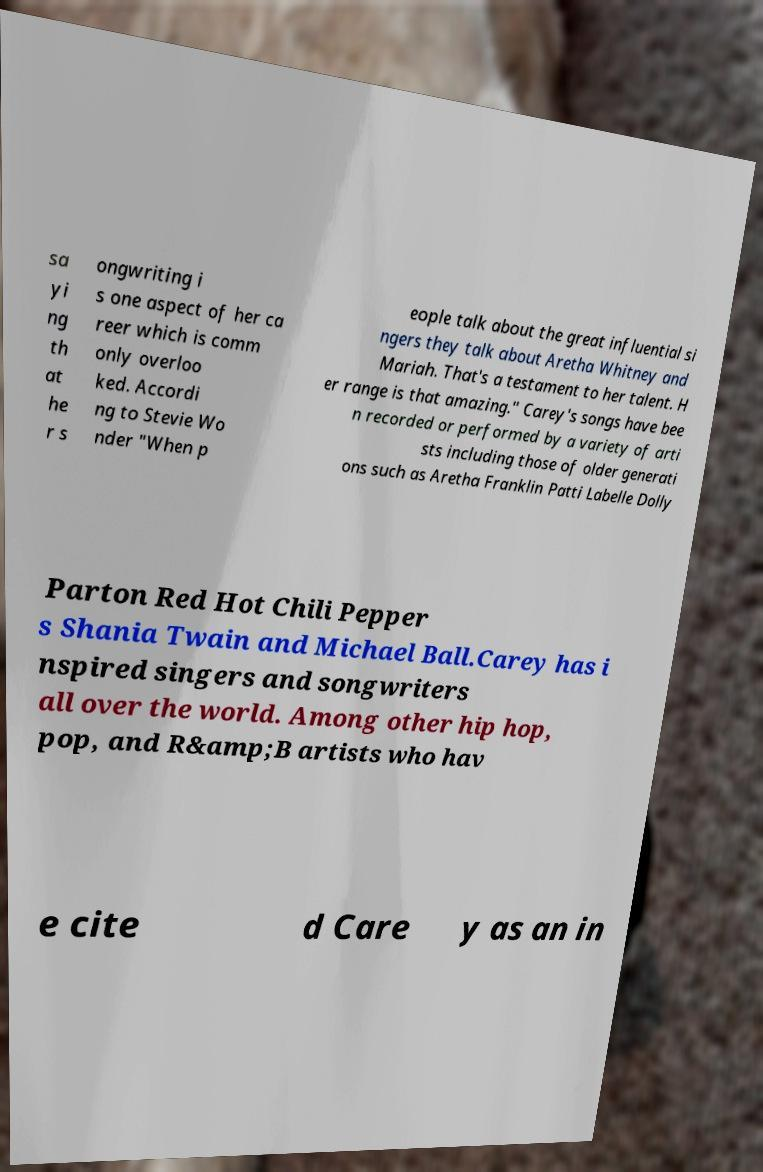I need the written content from this picture converted into text. Can you do that? sa yi ng th at he r s ongwriting i s one aspect of her ca reer which is comm only overloo ked. Accordi ng to Stevie Wo nder "When p eople talk about the great influential si ngers they talk about Aretha Whitney and Mariah. That's a testament to her talent. H er range is that amazing." Carey's songs have bee n recorded or performed by a variety of arti sts including those of older generati ons such as Aretha Franklin Patti Labelle Dolly Parton Red Hot Chili Pepper s Shania Twain and Michael Ball.Carey has i nspired singers and songwriters all over the world. Among other hip hop, pop, and R&amp;B artists who hav e cite d Care y as an in 